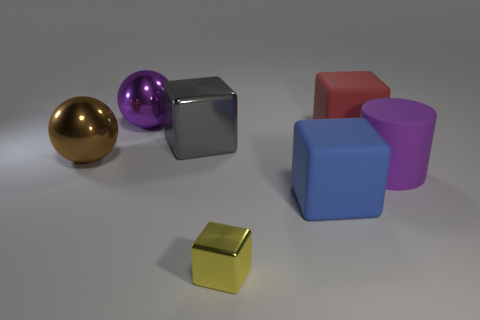What number of other objects are the same size as the gray metallic thing?
Give a very brief answer. 5. What material is the large thing on the left side of the metallic ball behind the gray object?
Your answer should be compact. Metal. There is a big purple shiny ball; are there any small yellow blocks behind it?
Keep it short and to the point. No. Is the number of large objects that are to the right of the yellow metallic thing greater than the number of big blue matte blocks?
Keep it short and to the point. Yes. Is there a large metal object that has the same color as the cylinder?
Give a very brief answer. Yes. There is another metal sphere that is the same size as the purple metallic sphere; what is its color?
Give a very brief answer. Brown. Is there a big purple thing on the right side of the large cube that is behind the large gray metal block?
Give a very brief answer. Yes. What is the material of the purple object that is left of the big metallic cube?
Give a very brief answer. Metal. Is the large purple thing that is on the left side of the gray block made of the same material as the large cube left of the large blue object?
Give a very brief answer. Yes. Is the number of purple balls in front of the big gray metal object the same as the number of big blocks that are to the right of the red block?
Give a very brief answer. Yes. 